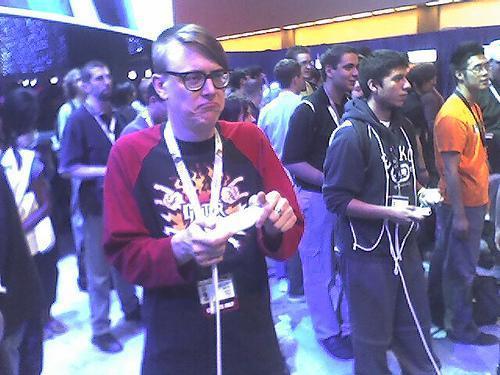How many people are in the picture?
Give a very brief answer. 8. 